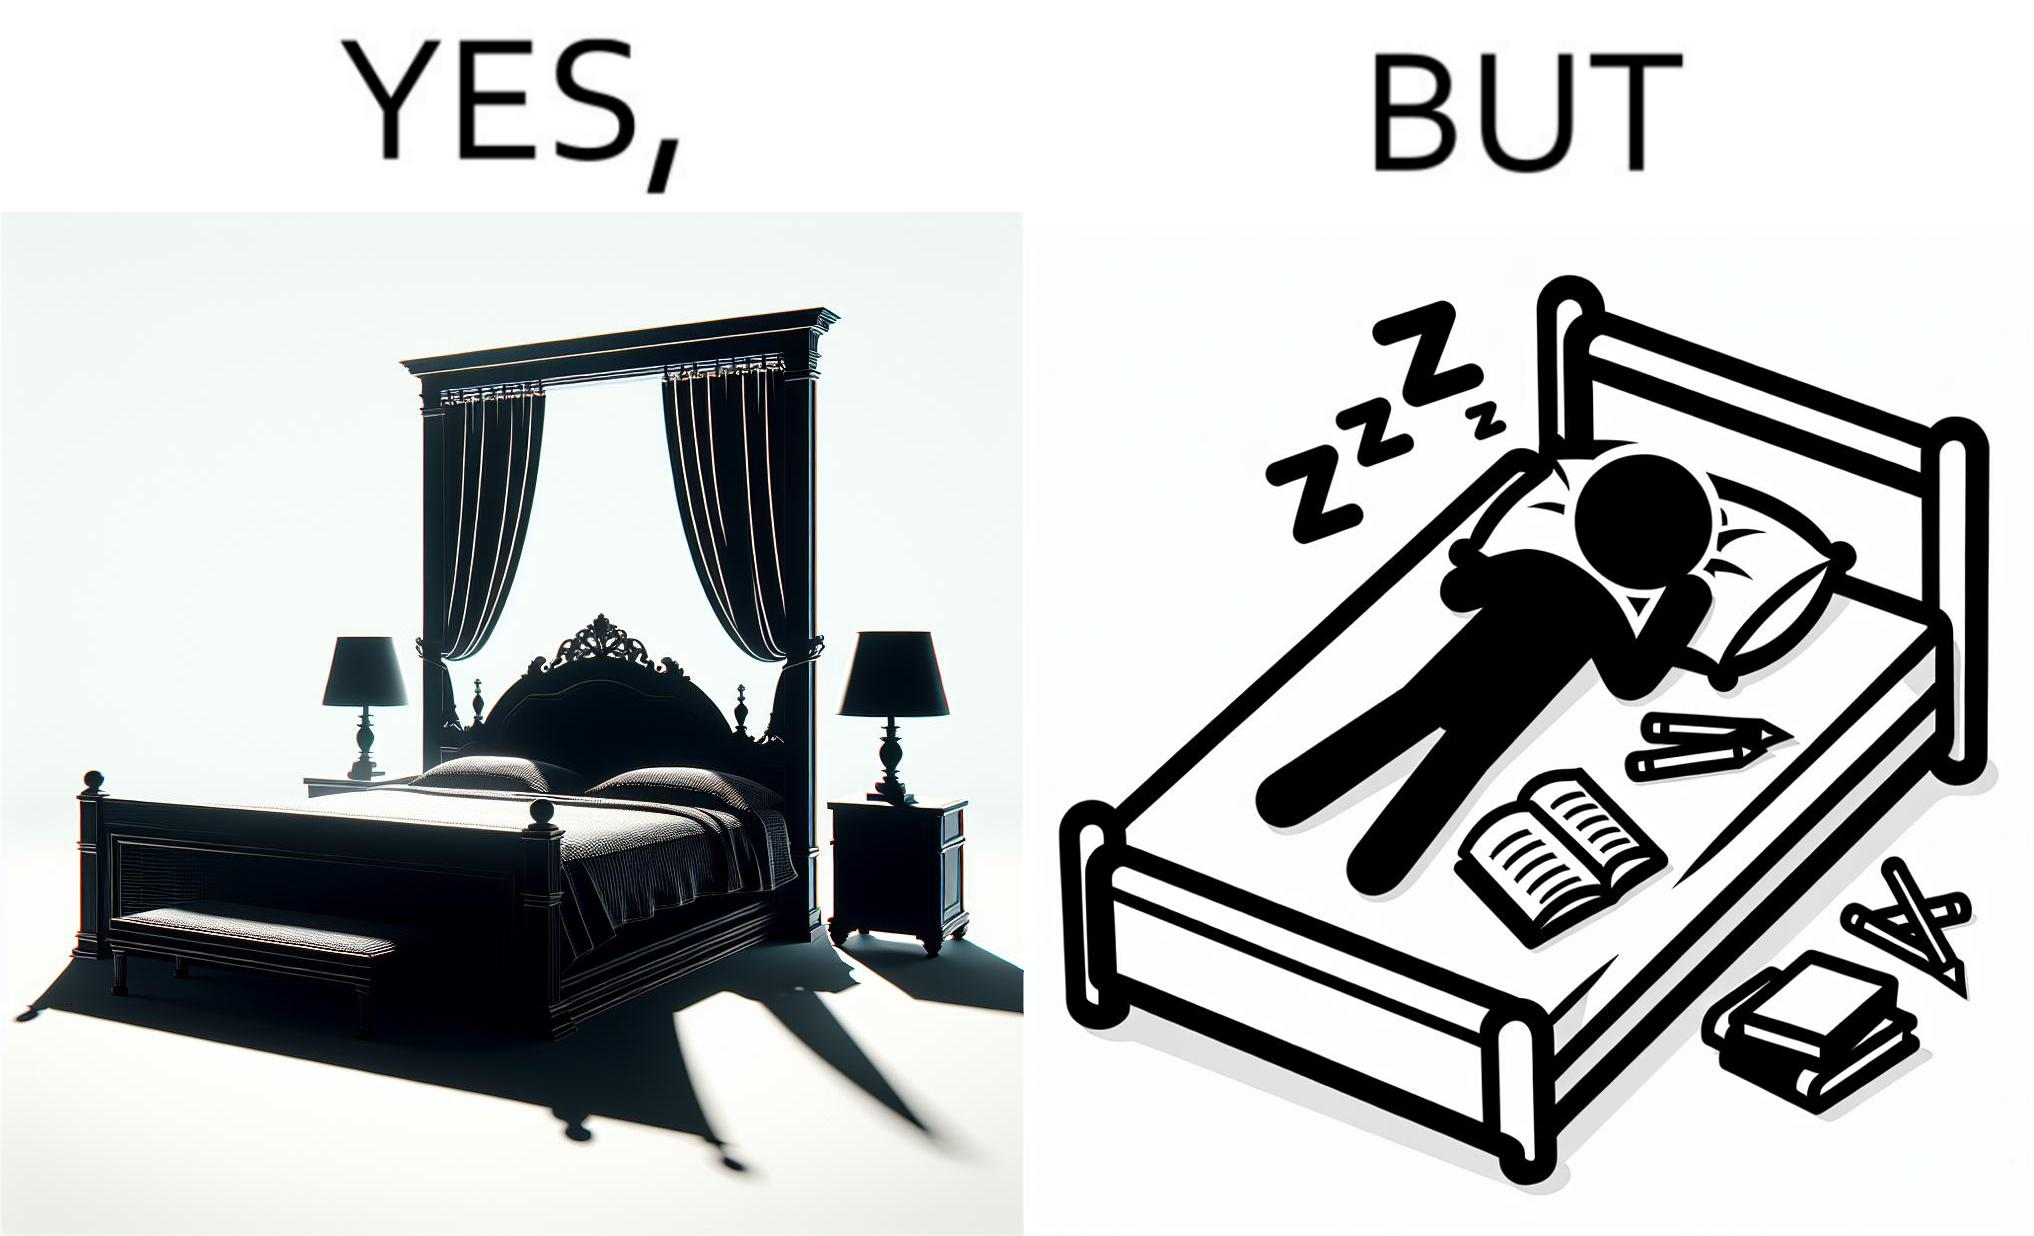What does this image depict? Although the person has purchased a king size bed, but only less than half of the space is used by the person for sleeping. 